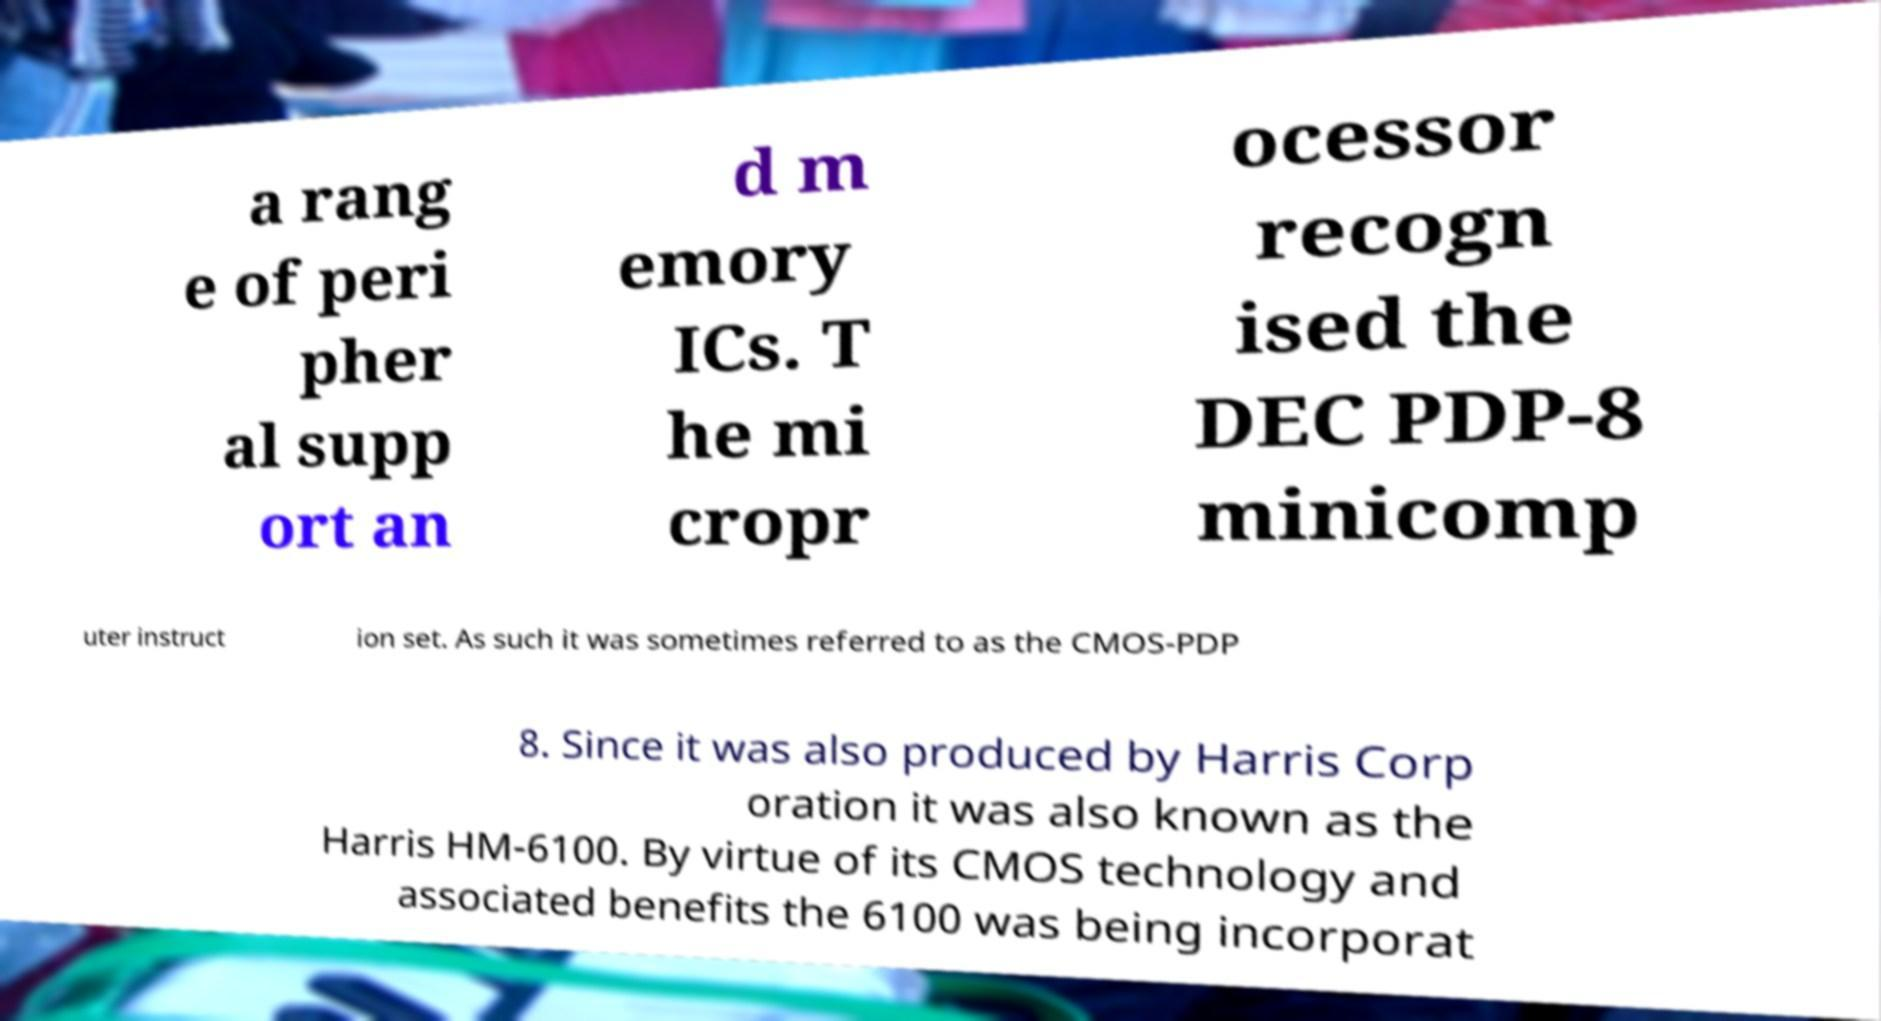I need the written content from this picture converted into text. Can you do that? a rang e of peri pher al supp ort an d m emory ICs. T he mi cropr ocessor recogn ised the DEC PDP-8 minicomp uter instruct ion set. As such it was sometimes referred to as the CMOS-PDP 8. Since it was also produced by Harris Corp oration it was also known as the Harris HM-6100. By virtue of its CMOS technology and associated benefits the 6100 was being incorporat 